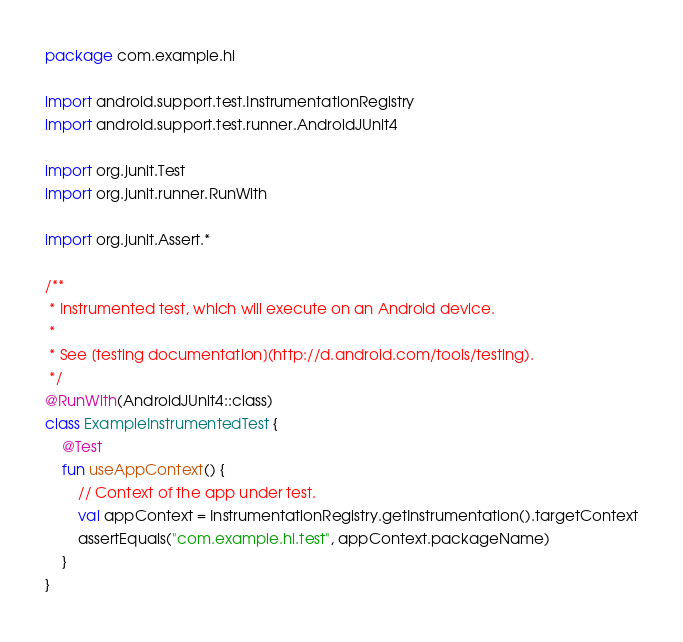<code> <loc_0><loc_0><loc_500><loc_500><_Kotlin_>package com.example.hi

import android.support.test.InstrumentationRegistry
import android.support.test.runner.AndroidJUnit4

import org.junit.Test
import org.junit.runner.RunWith

import org.junit.Assert.*

/**
 * Instrumented test, which will execute on an Android device.
 *
 * See [testing documentation](http://d.android.com/tools/testing).
 */
@RunWith(AndroidJUnit4::class)
class ExampleInstrumentedTest {
    @Test
    fun useAppContext() {
        // Context of the app under test.
        val appContext = InstrumentationRegistry.getInstrumentation().targetContext
        assertEquals("com.example.hi.test", appContext.packageName)
    }
}</code> 